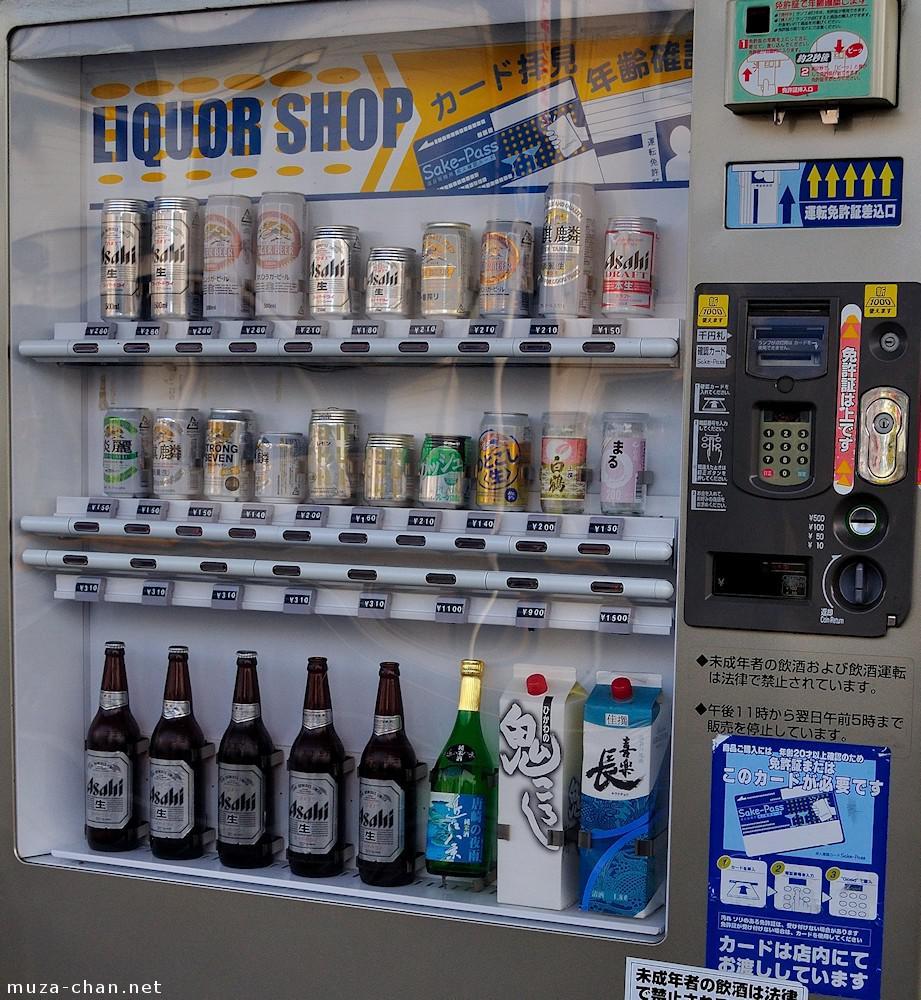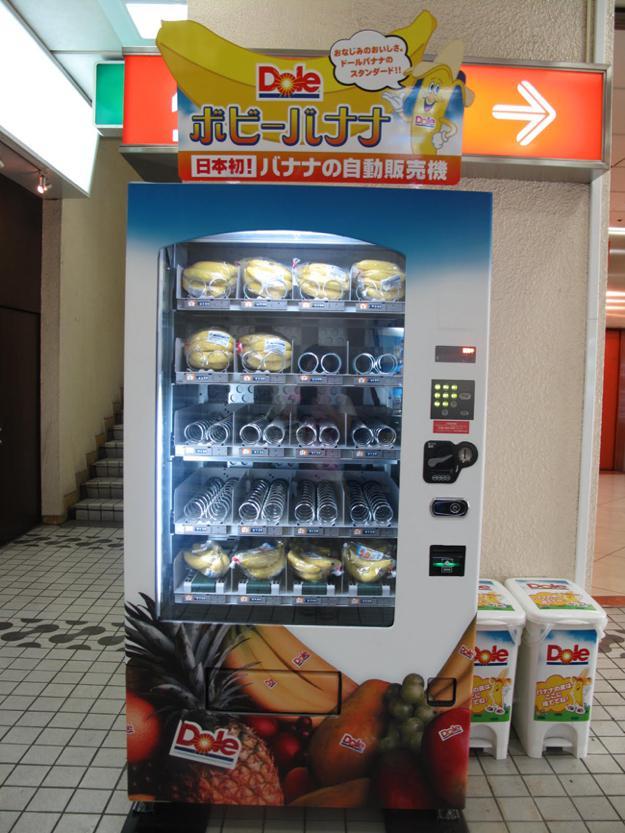The first image is the image on the left, the second image is the image on the right. Considering the images on both sides, is "There is a red vending machine in one of the images" valid? Answer yes or no. No. The first image is the image on the left, the second image is the image on the right. Considering the images on both sides, is "One of the images contains more than one vending machine." valid? Answer yes or no. No. 